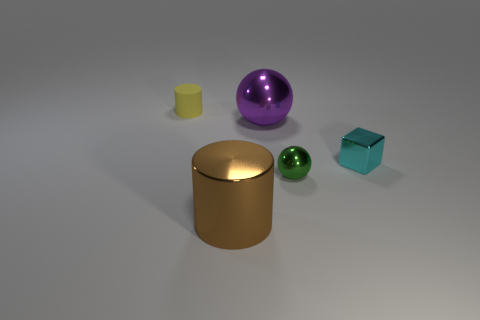Is the number of things that are in front of the cyan shiny thing greater than the number of tiny balls?
Ensure brevity in your answer.  Yes. Is the shape of the tiny cyan metallic object the same as the small metallic object that is on the left side of the shiny cube?
Your response must be concise. No. What number of blue blocks are the same size as the brown object?
Offer a terse response. 0. There is a cylinder on the left side of the large shiny thing that is in front of the tiny sphere; how many small cyan cubes are on the right side of it?
Your response must be concise. 1. Is the number of big brown metallic things to the right of the metallic cylinder the same as the number of metallic objects behind the small cyan metal object?
Your answer should be very brief. No. How many other tiny purple matte objects are the same shape as the tiny rubber thing?
Provide a succinct answer. 0. Is there a small cylinder made of the same material as the green object?
Provide a succinct answer. No. What number of big purple metal balls are there?
Your answer should be compact. 1. How many blocks are either big cyan matte things or large purple things?
Provide a short and direct response. 0. What color is the shiny thing that is the same size as the brown metal cylinder?
Ensure brevity in your answer.  Purple. 